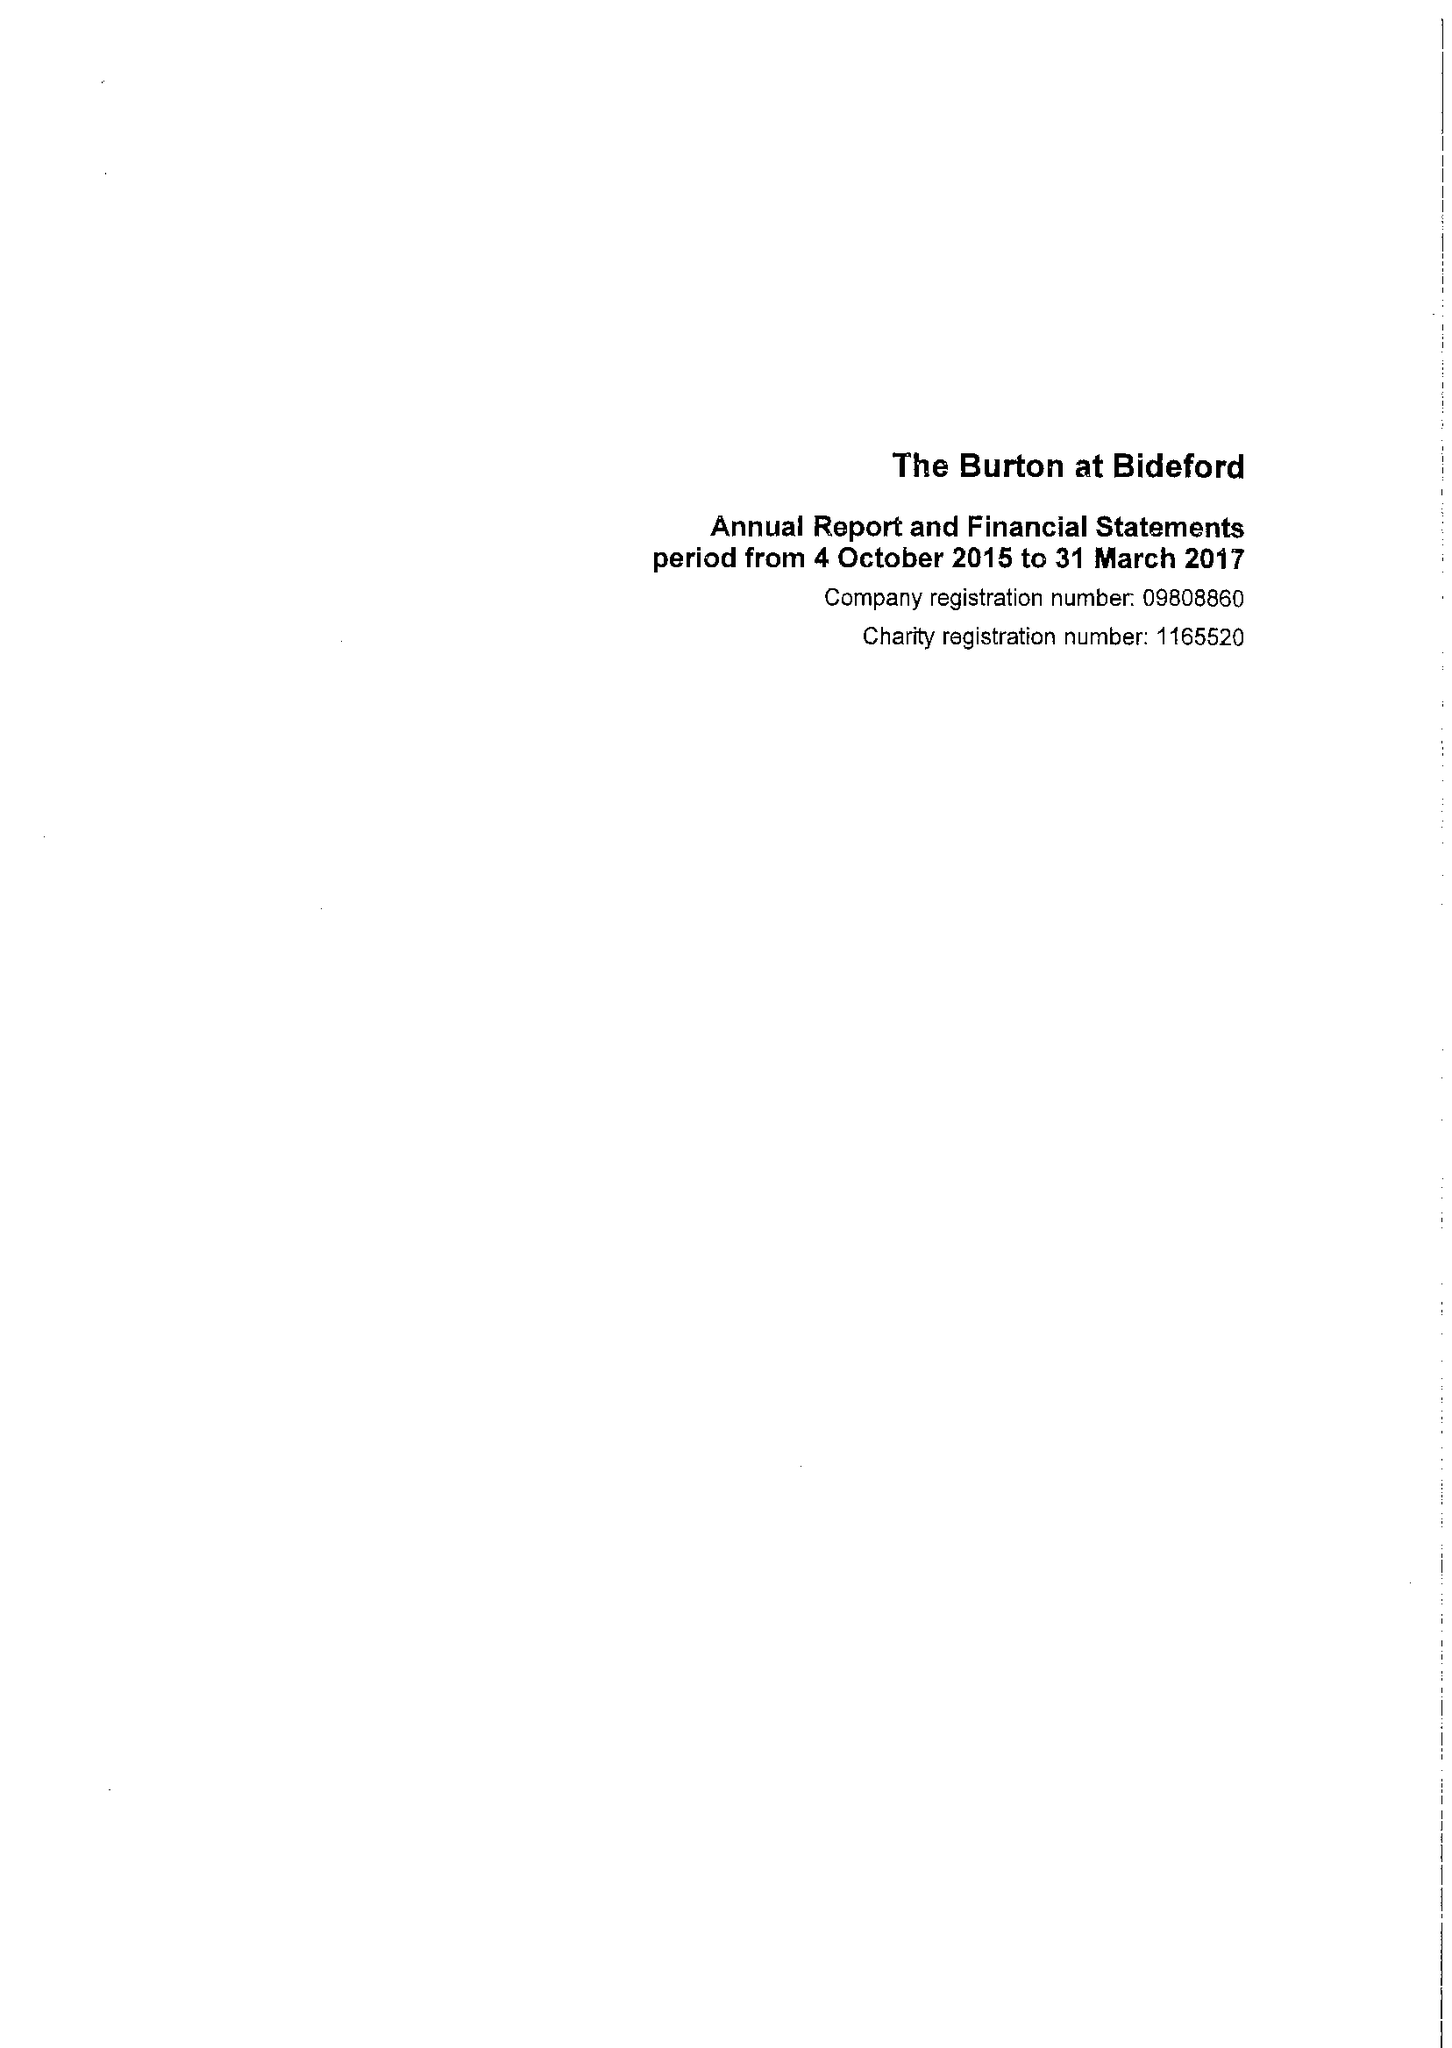What is the value for the charity_number?
Answer the question using a single word or phrase. 1165520 